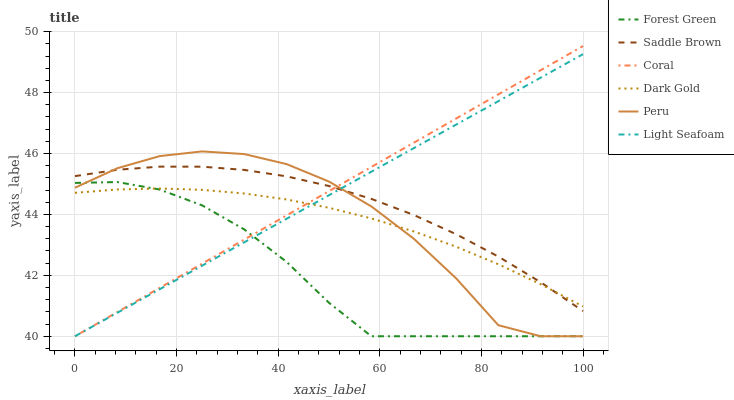Does Forest Green have the minimum area under the curve?
Answer yes or no. Yes. Does Coral have the maximum area under the curve?
Answer yes or no. Yes. Does Coral have the minimum area under the curve?
Answer yes or no. No. Does Forest Green have the maximum area under the curve?
Answer yes or no. No. Is Coral the smoothest?
Answer yes or no. Yes. Is Peru the roughest?
Answer yes or no. Yes. Is Forest Green the smoothest?
Answer yes or no. No. Is Forest Green the roughest?
Answer yes or no. No. Does Coral have the lowest value?
Answer yes or no. Yes. Does Saddle Brown have the lowest value?
Answer yes or no. No. Does Coral have the highest value?
Answer yes or no. Yes. Does Forest Green have the highest value?
Answer yes or no. No. Is Forest Green less than Saddle Brown?
Answer yes or no. Yes. Is Saddle Brown greater than Forest Green?
Answer yes or no. Yes. Does Light Seafoam intersect Forest Green?
Answer yes or no. Yes. Is Light Seafoam less than Forest Green?
Answer yes or no. No. Is Light Seafoam greater than Forest Green?
Answer yes or no. No. Does Forest Green intersect Saddle Brown?
Answer yes or no. No. 